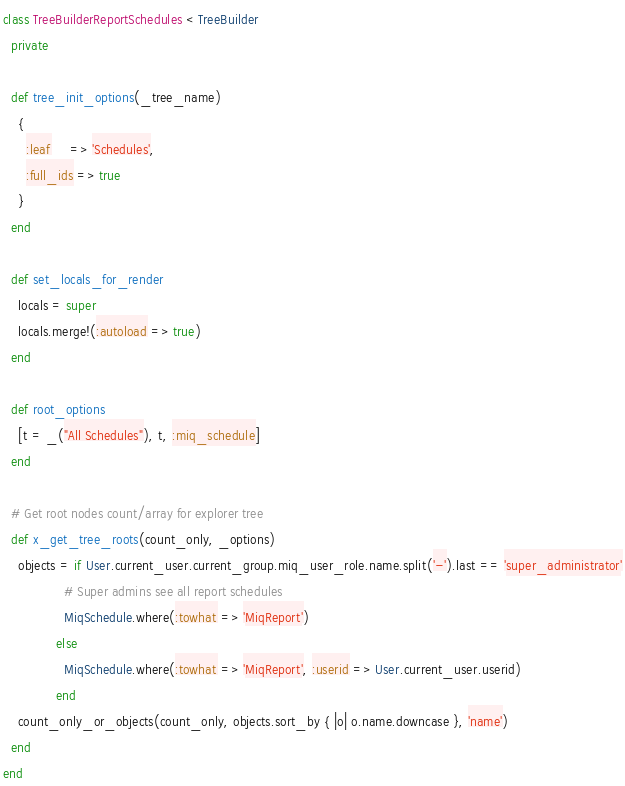<code> <loc_0><loc_0><loc_500><loc_500><_Ruby_>class TreeBuilderReportSchedules < TreeBuilder
  private

  def tree_init_options(_tree_name)
    {
      :leaf     => 'Schedules',
      :full_ids => true
    }
  end

  def set_locals_for_render
    locals = super
    locals.merge!(:autoload => true)
  end

  def root_options
    [t = _("All Schedules"), t, :miq_schedule]
  end

  # Get root nodes count/array for explorer tree
  def x_get_tree_roots(count_only, _options)
    objects = if User.current_user.current_group.miq_user_role.name.split('-').last == 'super_administrator'
                # Super admins see all report schedules
                MiqSchedule.where(:towhat => 'MiqReport')
              else
                MiqSchedule.where(:towhat => 'MiqReport', :userid => User.current_user.userid)
              end
    count_only_or_objects(count_only, objects.sort_by { |o| o.name.downcase }, 'name')
  end
end
</code> 